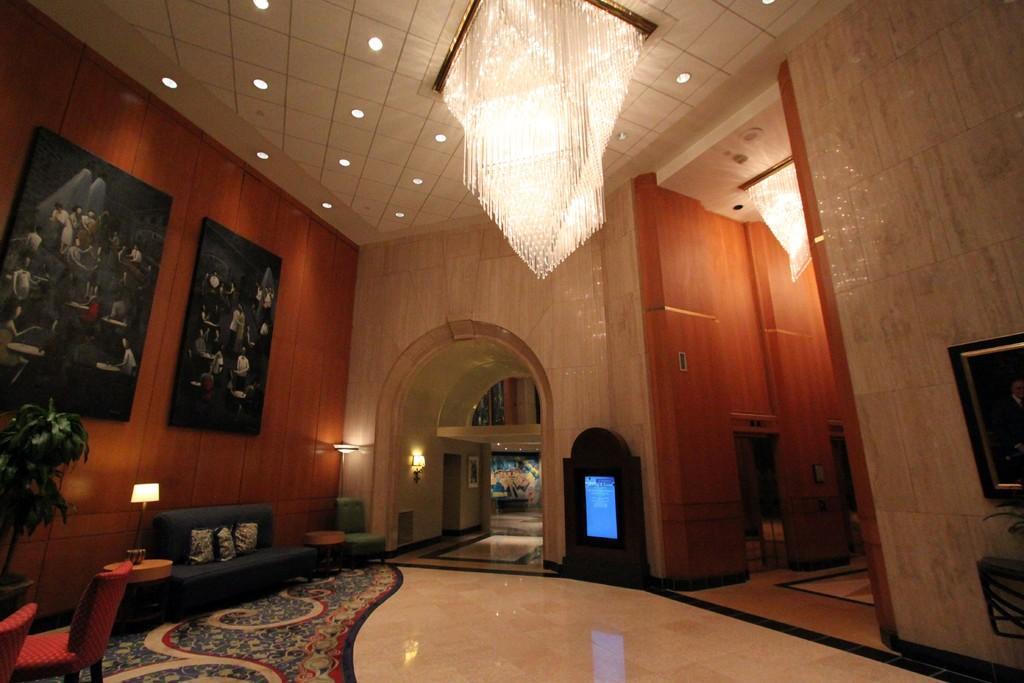Can you describe this image briefly? Here we can see an inner view of a house at the top there is chandelier at the left side of the walls there are couple of portraits at the left side we can see couch with cushions on it here at the left side there is a plant at the left side bottom we can see chairs and there are number of lights present 